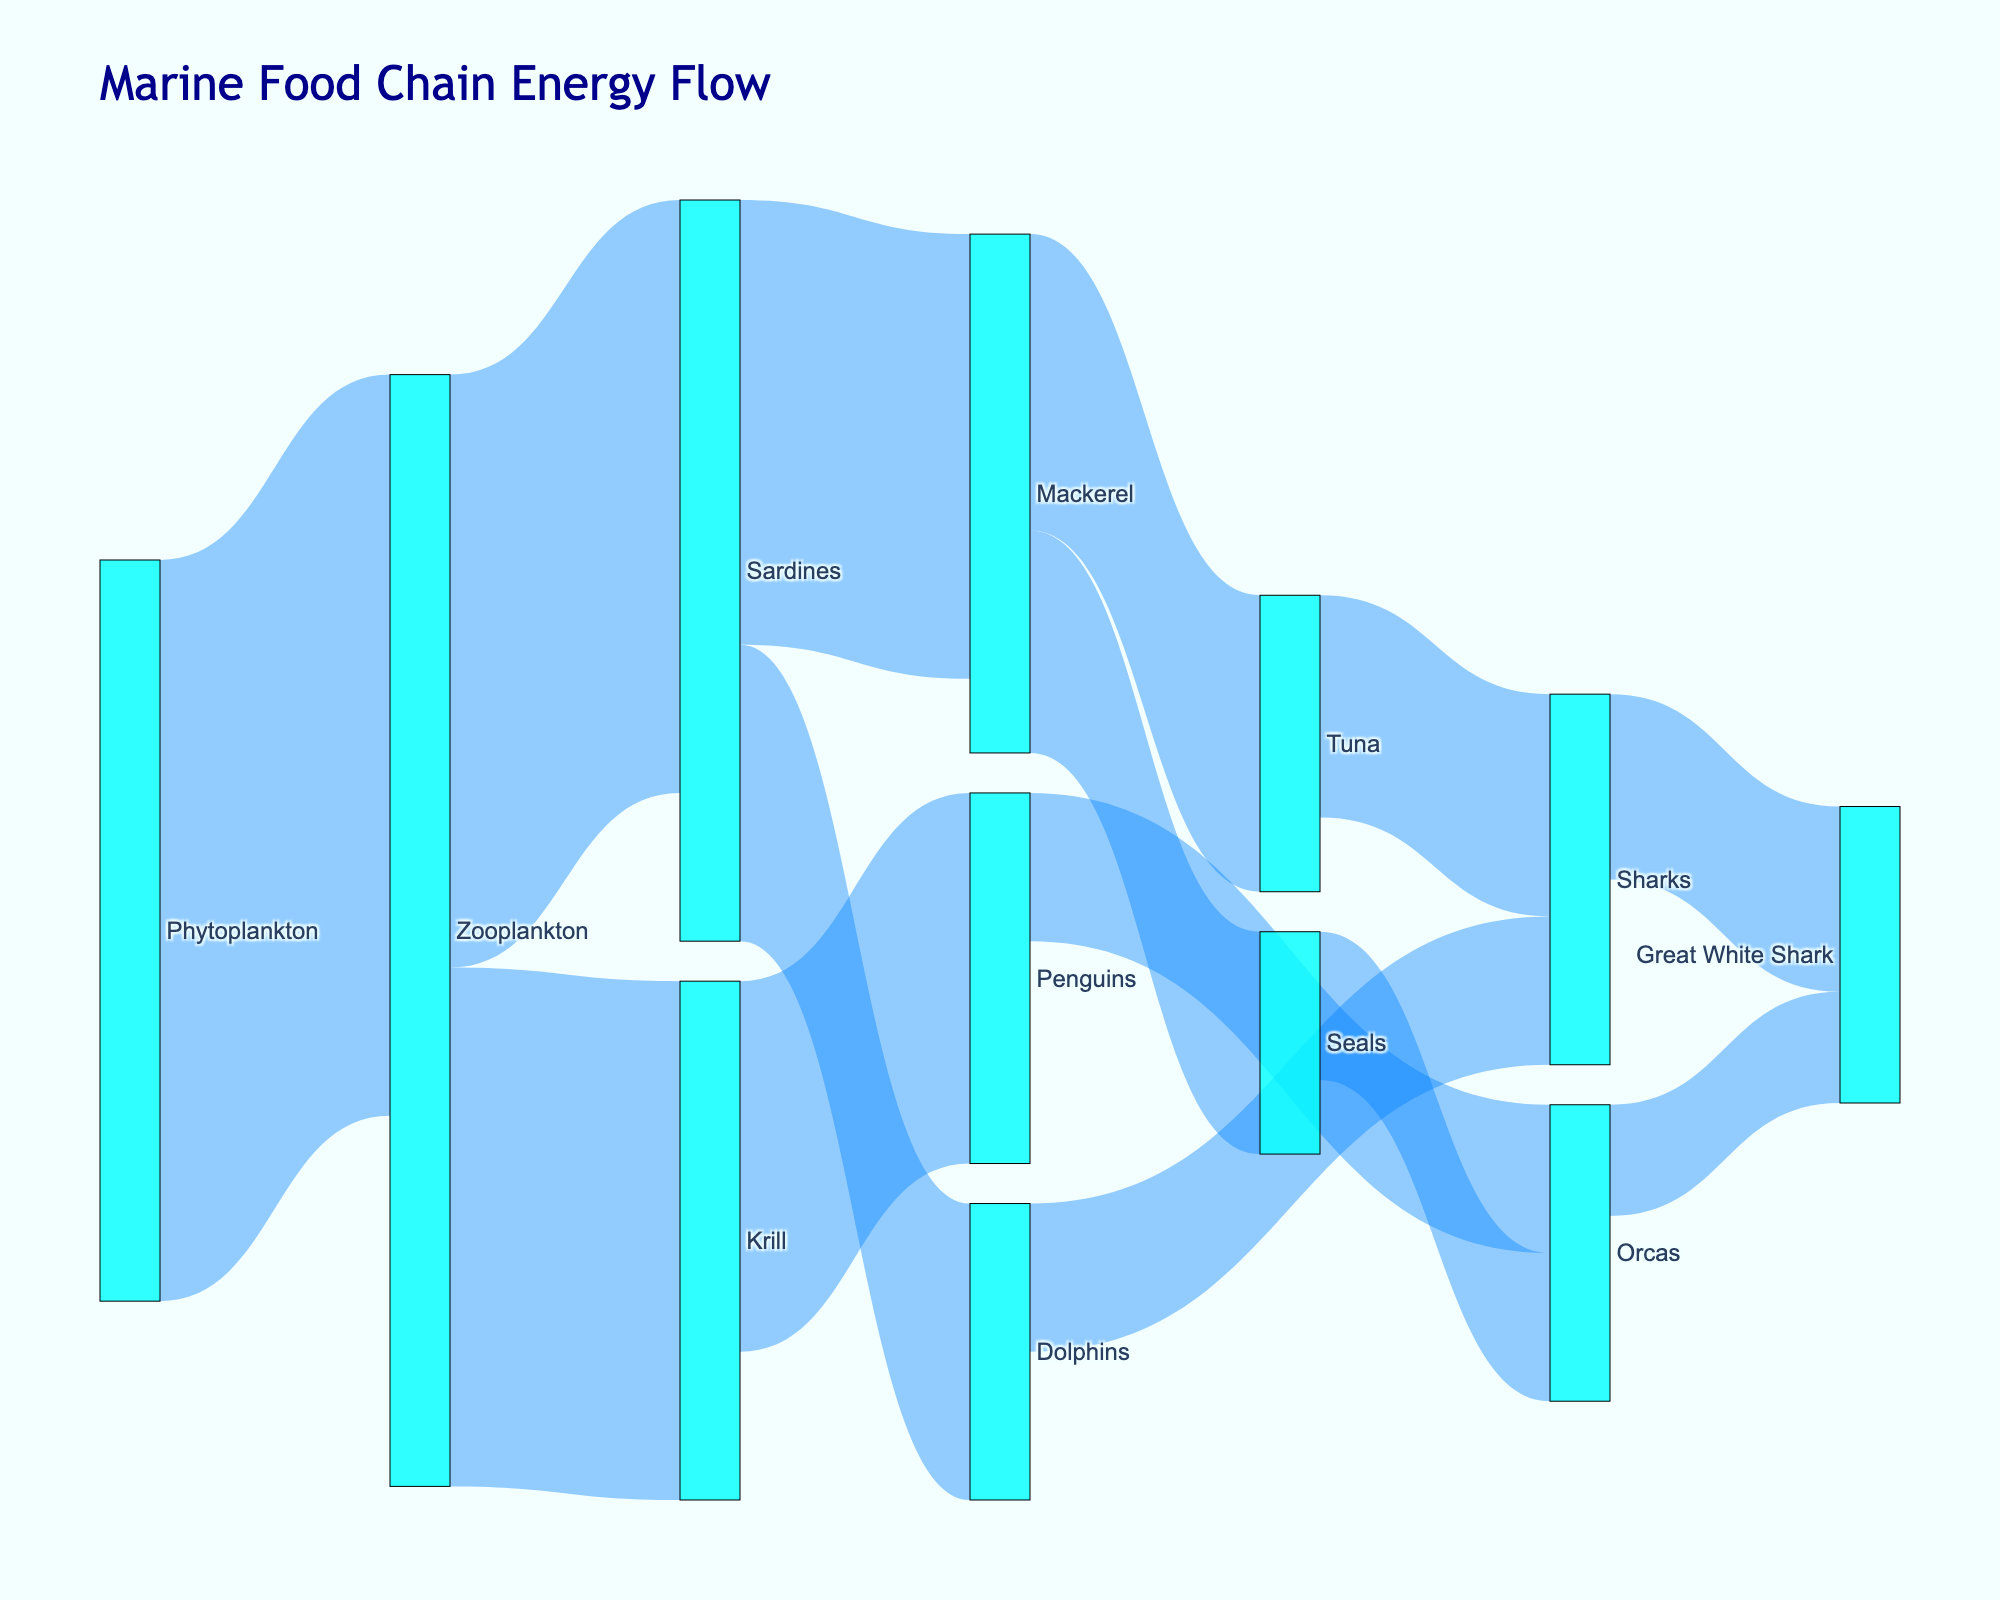What's the title of the figure? The title is often clearly visible at the top of a Sankey Diagram. In this case, the title reads "Marine Food Chain Energy Flow" based on the provided code.
Answer: Marine Food Chain Energy Flow Which species receives energy from the most different sources? By following the flow lines going into each species' node, you can see which species has the most incoming connections. Both the "Great White Shark" and the "Sharks" receive energy from two sources each (Orcas and Sharks for the Great White Shark, and both Tuna and Dolphins for Sharks).
Answer: Great White Shark, Sharks How much energy flows from Zooplankton to Sardines? Look at the link connecting Zooplankton to Sardines and see the number associated with the flow, which in this case is 800.
Answer: 800 What is the total energy that flows into Orcas? To find the total, sum the energy values of all links ending at Orcas. These are from Penguins (200) and Seals (200). So, 200 + 200 = 400.
Answer: 400 Compare the energy flow from Sardines to Mackerel and Dolphins. Which one is higher? Look at the values of the flows from Sardines to Mackerel (600) and from Sardines to Dolphins (400). 600 is greater than 400.
Answer: Flow to Mackerel Which species provide energy to the Great White Shark? Identify the sources connecting to the Great White Shark. The sources are Orcas and Sharks.
Answer: Orcas, Sharks What is the total energy originating from Zooplankton? Sum the energy values of all flows that Zooplankton directs to other species: Sardines (800) and Krill (700). So, 800 + 700 = 1500.
Answer: 1500 Among the top-level producers and the apex predators, describe the color scheme used in the nodes. The nodes for both producers and apex predators are colored in a cyan-like color based on the provided code where all nodes are given the same color.
Answer: Cyan color What's the difference in energy flow between the Sardines to Mackerel link and the Krill to Penguins link? Determine the values for each link: Sardines to Mackerel (600) and Krill to Penguins (500). The difference is 600 - 500 = 100.
Answer: 100 How many species act as intermediaries between primary producers and apex predators? Count the number of species that have flows both into and out of them and are between the first producers (Phytoplankton) and apex predators (Great White Shark). In this case, there are Zooplankton, Sardines, Mackerel, Krill, Penguins, Tuna, Seals, Dolphins, Sharks, and Orcas, but only Zooplankton, Sardines, Krill, Mackerel, Tuna, Seals, Penguins, and Dolphins serve as intermediaries.
Answer: 8 